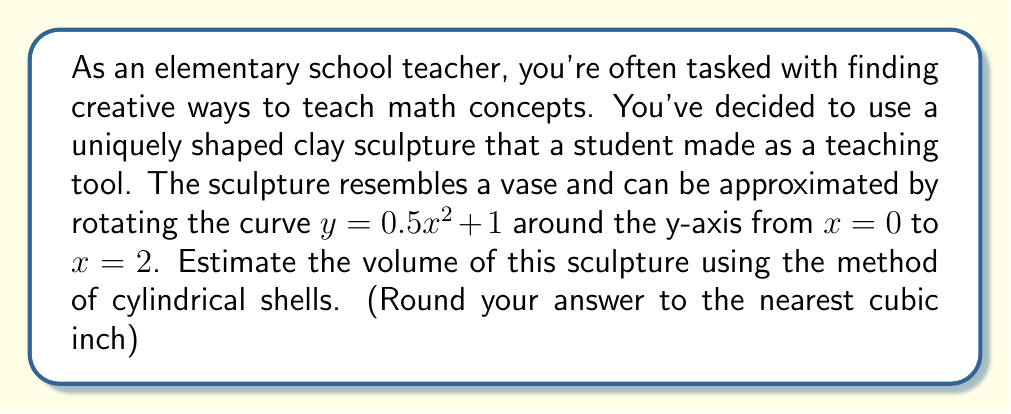Teach me how to tackle this problem. Let's approach this step-by-step:

1) The method of cylindrical shells uses the formula:
   
   $$ V = 2\pi \int_a^b x f(x) dx $$

   where $x$ is the radius of each shell and $f(x)$ is the height of the shell.

2) In this case, $f(x) = 0.5x^2 + 1$, $a = 0$, and $b = 2$.

3) Substituting these into our formula:

   $$ V = 2\pi \int_0^2 x (0.5x^2 + 1) dx $$

4) Expand the integrand:

   $$ V = 2\pi \int_0^2 (0.5x^3 + x) dx $$

5) Integrate:

   $$ V = 2\pi [\frac{1}{8}x^4 + \frac{1}{2}x^2]_0^2 $$

6) Evaluate the integral:

   $$ V = 2\pi [(\frac{1}{8}(2^4) + \frac{1}{2}(2^2)) - (\frac{1}{8}(0^4) + \frac{1}{2}(0^2))] $$
   $$ V = 2\pi [\frac{16}{8} + 2 - 0] $$
   $$ V = 2\pi [4] $$
   $$ V = 8\pi $$

7) Calculate and round to the nearest cubic inch:

   $$ V \approx 25.13 \approx 25 \text{ cubic inches} $$
Answer: The estimated volume of the sculpture is approximately 25 cubic inches. 